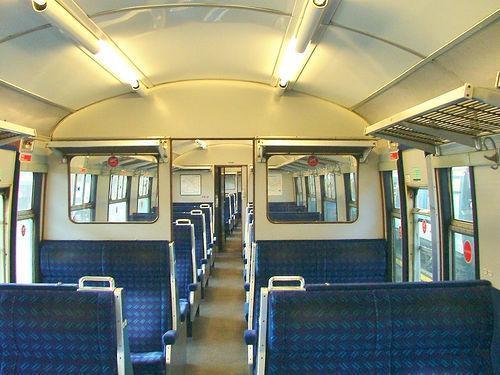How many aisles are shown?
Give a very brief answer. 1. 